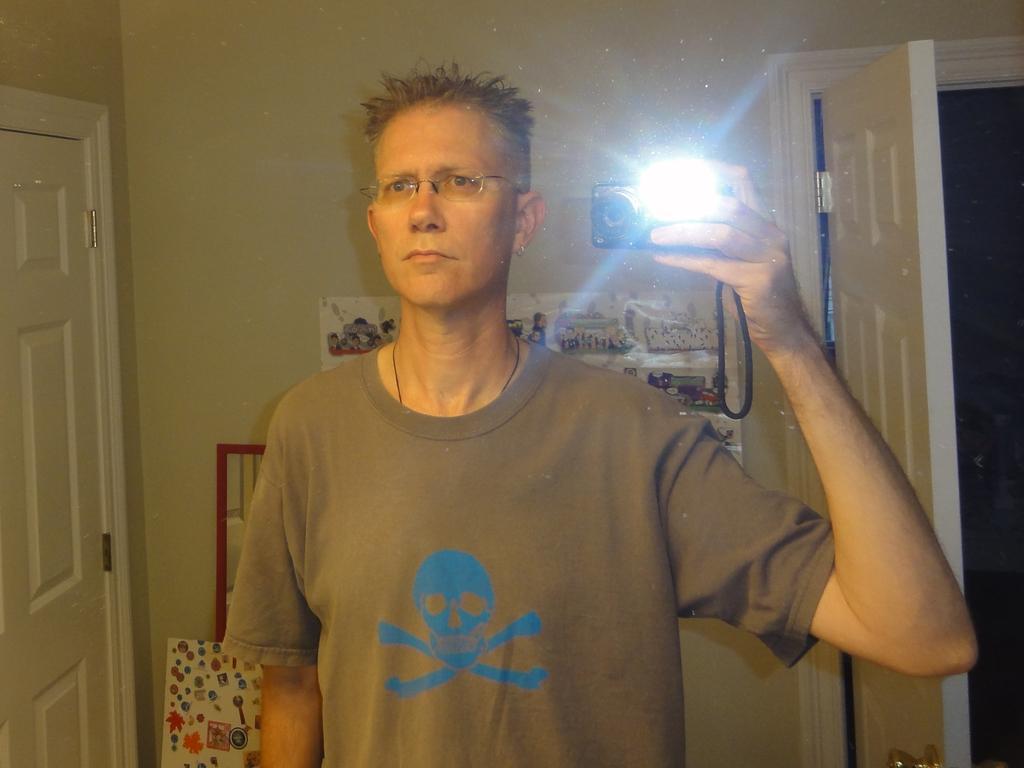Please provide a concise description of this image. In this image we can see a person wearing brown color T-shirt also wearing spectacles, holding mobile phone in his hands and in the background of the image there is a wall, doors and some pictures attached to the wall. 